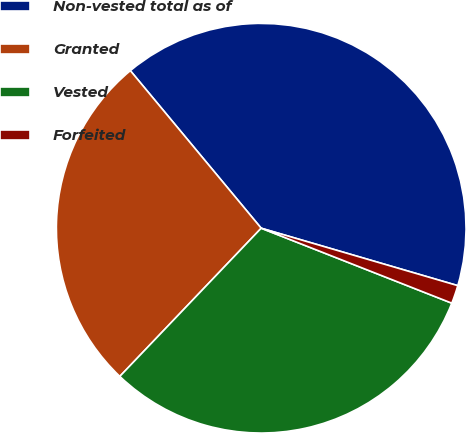<chart> <loc_0><loc_0><loc_500><loc_500><pie_chart><fcel>Non-vested total as of<fcel>Granted<fcel>Vested<fcel>Forfeited<nl><fcel>40.55%<fcel>26.84%<fcel>31.16%<fcel>1.44%<nl></chart> 